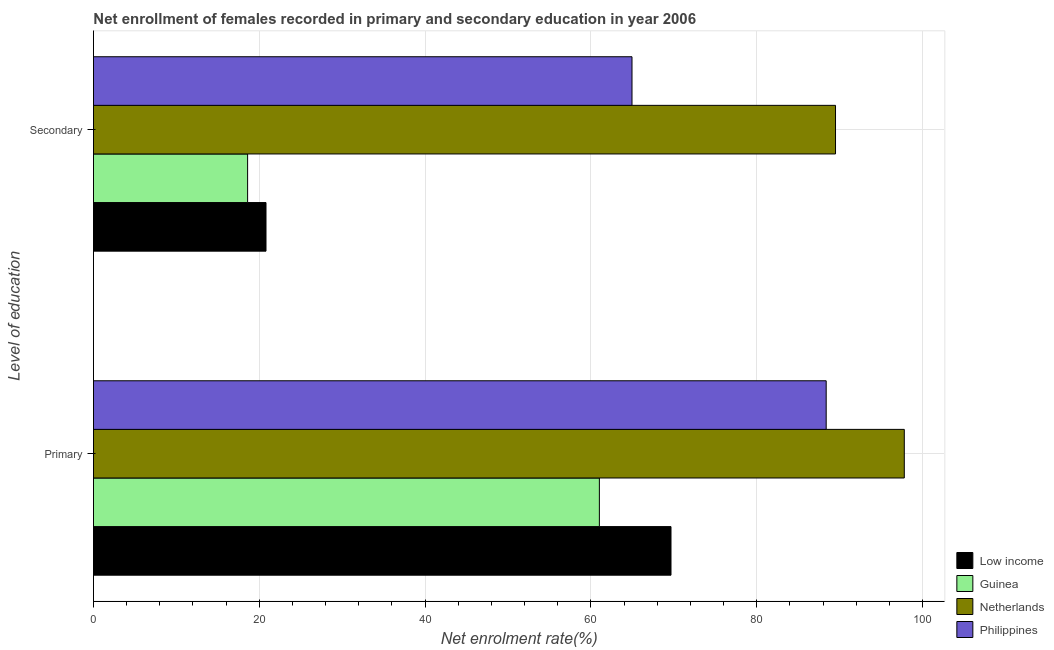Are the number of bars per tick equal to the number of legend labels?
Give a very brief answer. Yes. Are the number of bars on each tick of the Y-axis equal?
Give a very brief answer. Yes. How many bars are there on the 2nd tick from the top?
Ensure brevity in your answer.  4. How many bars are there on the 1st tick from the bottom?
Ensure brevity in your answer.  4. What is the label of the 1st group of bars from the top?
Make the answer very short. Secondary. What is the enrollment rate in secondary education in Netherlands?
Provide a short and direct response. 89.5. Across all countries, what is the maximum enrollment rate in primary education?
Give a very brief answer. 97.8. Across all countries, what is the minimum enrollment rate in primary education?
Keep it short and to the point. 61.02. In which country was the enrollment rate in primary education minimum?
Ensure brevity in your answer.  Guinea. What is the total enrollment rate in primary education in the graph?
Offer a terse response. 316.86. What is the difference between the enrollment rate in secondary education in Guinea and that in Netherlands?
Your answer should be compact. -70.91. What is the difference between the enrollment rate in primary education in Low income and the enrollment rate in secondary education in Philippines?
Ensure brevity in your answer.  4.7. What is the average enrollment rate in primary education per country?
Give a very brief answer. 79.22. What is the difference between the enrollment rate in primary education and enrollment rate in secondary education in Low income?
Your response must be concise. 48.85. In how many countries, is the enrollment rate in secondary education greater than 44 %?
Provide a succinct answer. 2. What is the ratio of the enrollment rate in secondary education in Netherlands to that in Low income?
Offer a very short reply. 4.3. Is the enrollment rate in secondary education in Netherlands less than that in Philippines?
Offer a very short reply. No. In how many countries, is the enrollment rate in primary education greater than the average enrollment rate in primary education taken over all countries?
Your answer should be compact. 2. What does the 3rd bar from the top in Primary represents?
Offer a very short reply. Guinea. What does the 1st bar from the bottom in Secondary represents?
Your answer should be compact. Low income. How many bars are there?
Your answer should be compact. 8. Are all the bars in the graph horizontal?
Offer a terse response. Yes. How many countries are there in the graph?
Make the answer very short. 4. What is the difference between two consecutive major ticks on the X-axis?
Keep it short and to the point. 20. Are the values on the major ticks of X-axis written in scientific E-notation?
Your answer should be compact. No. Does the graph contain any zero values?
Provide a succinct answer. No. How many legend labels are there?
Provide a succinct answer. 4. How are the legend labels stacked?
Provide a succinct answer. Vertical. What is the title of the graph?
Give a very brief answer. Net enrollment of females recorded in primary and secondary education in year 2006. What is the label or title of the X-axis?
Ensure brevity in your answer.  Net enrolment rate(%). What is the label or title of the Y-axis?
Your response must be concise. Level of education. What is the Net enrolment rate(%) in Low income in Primary?
Ensure brevity in your answer.  69.66. What is the Net enrolment rate(%) of Guinea in Primary?
Offer a very short reply. 61.02. What is the Net enrolment rate(%) in Netherlands in Primary?
Your answer should be very brief. 97.8. What is the Net enrolment rate(%) in Philippines in Primary?
Your answer should be very brief. 88.38. What is the Net enrolment rate(%) of Low income in Secondary?
Offer a terse response. 20.81. What is the Net enrolment rate(%) of Guinea in Secondary?
Offer a very short reply. 18.59. What is the Net enrolment rate(%) in Netherlands in Secondary?
Your answer should be compact. 89.5. What is the Net enrolment rate(%) in Philippines in Secondary?
Make the answer very short. 64.96. Across all Level of education, what is the maximum Net enrolment rate(%) in Low income?
Offer a terse response. 69.66. Across all Level of education, what is the maximum Net enrolment rate(%) of Guinea?
Ensure brevity in your answer.  61.02. Across all Level of education, what is the maximum Net enrolment rate(%) of Netherlands?
Give a very brief answer. 97.8. Across all Level of education, what is the maximum Net enrolment rate(%) of Philippines?
Keep it short and to the point. 88.38. Across all Level of education, what is the minimum Net enrolment rate(%) in Low income?
Make the answer very short. 20.81. Across all Level of education, what is the minimum Net enrolment rate(%) in Guinea?
Your answer should be very brief. 18.59. Across all Level of education, what is the minimum Net enrolment rate(%) in Netherlands?
Give a very brief answer. 89.5. Across all Level of education, what is the minimum Net enrolment rate(%) in Philippines?
Ensure brevity in your answer.  64.96. What is the total Net enrolment rate(%) of Low income in the graph?
Provide a short and direct response. 90.47. What is the total Net enrolment rate(%) in Guinea in the graph?
Your answer should be compact. 79.61. What is the total Net enrolment rate(%) in Netherlands in the graph?
Your response must be concise. 187.3. What is the total Net enrolment rate(%) of Philippines in the graph?
Make the answer very short. 153.34. What is the difference between the Net enrolment rate(%) in Low income in Primary and that in Secondary?
Provide a succinct answer. 48.85. What is the difference between the Net enrolment rate(%) of Guinea in Primary and that in Secondary?
Make the answer very short. 42.43. What is the difference between the Net enrolment rate(%) in Netherlands in Primary and that in Secondary?
Offer a very short reply. 8.3. What is the difference between the Net enrolment rate(%) of Philippines in Primary and that in Secondary?
Provide a short and direct response. 23.42. What is the difference between the Net enrolment rate(%) in Low income in Primary and the Net enrolment rate(%) in Guinea in Secondary?
Offer a terse response. 51.07. What is the difference between the Net enrolment rate(%) in Low income in Primary and the Net enrolment rate(%) in Netherlands in Secondary?
Your answer should be compact. -19.84. What is the difference between the Net enrolment rate(%) of Low income in Primary and the Net enrolment rate(%) of Philippines in Secondary?
Offer a very short reply. 4.7. What is the difference between the Net enrolment rate(%) in Guinea in Primary and the Net enrolment rate(%) in Netherlands in Secondary?
Make the answer very short. -28.48. What is the difference between the Net enrolment rate(%) of Guinea in Primary and the Net enrolment rate(%) of Philippines in Secondary?
Keep it short and to the point. -3.94. What is the difference between the Net enrolment rate(%) of Netherlands in Primary and the Net enrolment rate(%) of Philippines in Secondary?
Keep it short and to the point. 32.84. What is the average Net enrolment rate(%) in Low income per Level of education?
Your answer should be very brief. 45.24. What is the average Net enrolment rate(%) in Guinea per Level of education?
Your answer should be very brief. 39.81. What is the average Net enrolment rate(%) in Netherlands per Level of education?
Offer a terse response. 93.65. What is the average Net enrolment rate(%) of Philippines per Level of education?
Offer a terse response. 76.67. What is the difference between the Net enrolment rate(%) of Low income and Net enrolment rate(%) of Guinea in Primary?
Provide a short and direct response. 8.64. What is the difference between the Net enrolment rate(%) in Low income and Net enrolment rate(%) in Netherlands in Primary?
Offer a very short reply. -28.14. What is the difference between the Net enrolment rate(%) in Low income and Net enrolment rate(%) in Philippines in Primary?
Provide a short and direct response. -18.72. What is the difference between the Net enrolment rate(%) in Guinea and Net enrolment rate(%) in Netherlands in Primary?
Ensure brevity in your answer.  -36.78. What is the difference between the Net enrolment rate(%) in Guinea and Net enrolment rate(%) in Philippines in Primary?
Provide a succinct answer. -27.36. What is the difference between the Net enrolment rate(%) in Netherlands and Net enrolment rate(%) in Philippines in Primary?
Offer a terse response. 9.42. What is the difference between the Net enrolment rate(%) in Low income and Net enrolment rate(%) in Guinea in Secondary?
Provide a short and direct response. 2.22. What is the difference between the Net enrolment rate(%) in Low income and Net enrolment rate(%) in Netherlands in Secondary?
Keep it short and to the point. -68.69. What is the difference between the Net enrolment rate(%) in Low income and Net enrolment rate(%) in Philippines in Secondary?
Offer a terse response. -44.15. What is the difference between the Net enrolment rate(%) in Guinea and Net enrolment rate(%) in Netherlands in Secondary?
Offer a terse response. -70.91. What is the difference between the Net enrolment rate(%) of Guinea and Net enrolment rate(%) of Philippines in Secondary?
Give a very brief answer. -46.37. What is the difference between the Net enrolment rate(%) in Netherlands and Net enrolment rate(%) in Philippines in Secondary?
Your answer should be very brief. 24.55. What is the ratio of the Net enrolment rate(%) of Low income in Primary to that in Secondary?
Keep it short and to the point. 3.35. What is the ratio of the Net enrolment rate(%) of Guinea in Primary to that in Secondary?
Make the answer very short. 3.28. What is the ratio of the Net enrolment rate(%) in Netherlands in Primary to that in Secondary?
Give a very brief answer. 1.09. What is the ratio of the Net enrolment rate(%) of Philippines in Primary to that in Secondary?
Your answer should be compact. 1.36. What is the difference between the highest and the second highest Net enrolment rate(%) of Low income?
Keep it short and to the point. 48.85. What is the difference between the highest and the second highest Net enrolment rate(%) in Guinea?
Your response must be concise. 42.43. What is the difference between the highest and the second highest Net enrolment rate(%) in Netherlands?
Make the answer very short. 8.3. What is the difference between the highest and the second highest Net enrolment rate(%) in Philippines?
Offer a very short reply. 23.42. What is the difference between the highest and the lowest Net enrolment rate(%) of Low income?
Keep it short and to the point. 48.85. What is the difference between the highest and the lowest Net enrolment rate(%) of Guinea?
Offer a very short reply. 42.43. What is the difference between the highest and the lowest Net enrolment rate(%) of Netherlands?
Give a very brief answer. 8.3. What is the difference between the highest and the lowest Net enrolment rate(%) of Philippines?
Ensure brevity in your answer.  23.42. 